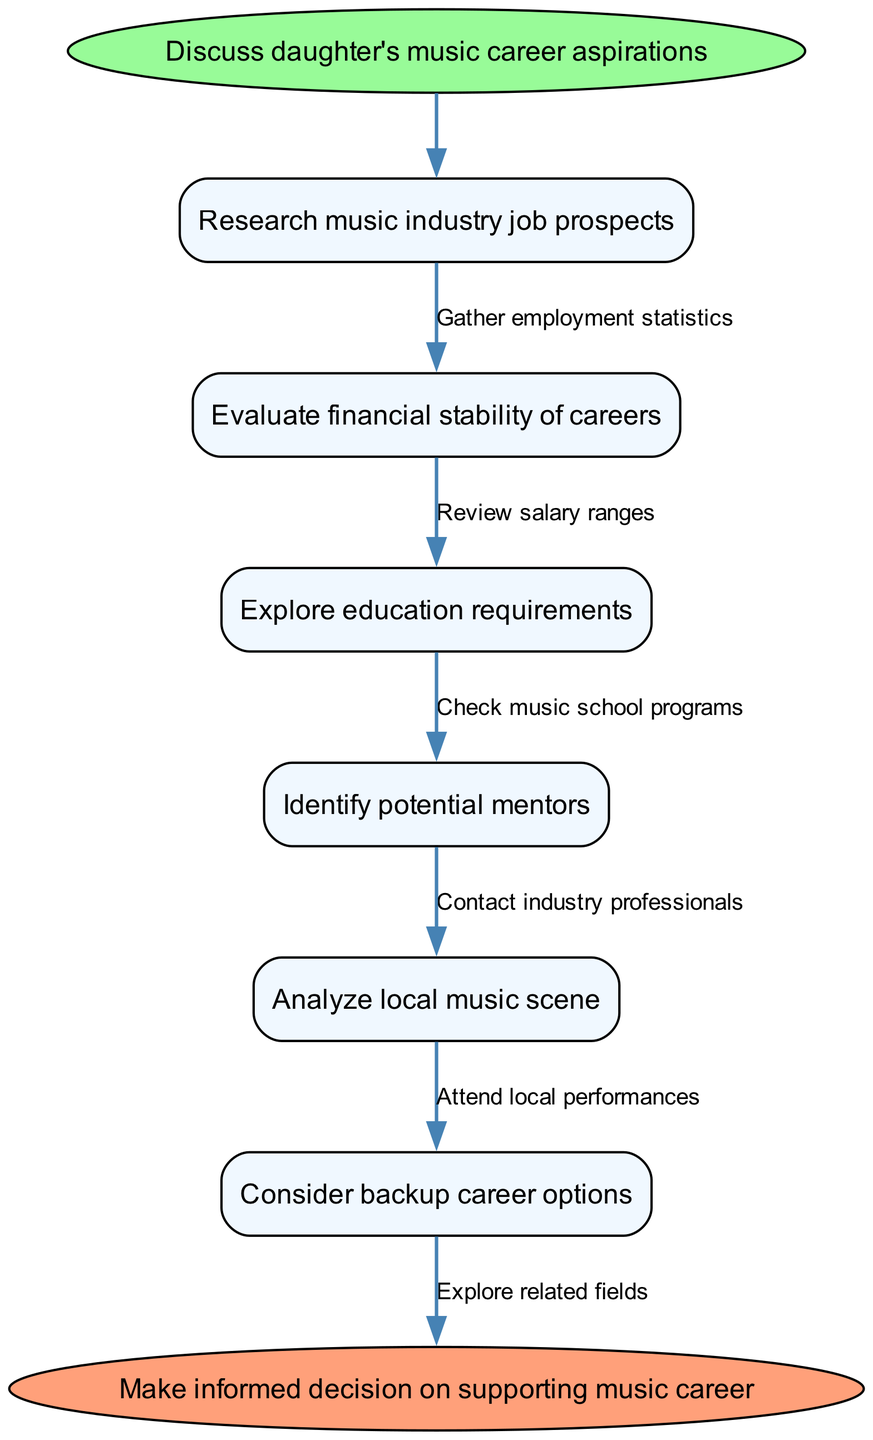What is the starting point of the flow chart? The starting point of the flow chart is indicated by a labeled ellipse node. In this case, it states "Discuss daughter's music career aspirations."
Answer: Discuss daughter's music career aspirations How many nodes are present in the diagram? By counting each unique action or stage in the flow chart, including start and end points, we find there are six nodes: 1 start node, 5 intermediate nodes, and 1 end node.
Answer: 7 What is the last step before making a decision? The last step in the flow chart, before reaching the end point, is the action labeled “Consider backup career options.” This indicates a critical evaluation step before making a final decision.
Answer: Consider backup career options Which node is directly connected to "Evaluate financial stability of careers"? The node "Evaluate financial stability of careers" is directly followed by "Explore education requirements." This means they are sequential in the flow of the diagram.
Answer: Explore education requirements What label is shown on the edge connecting "Research music industry job prospects" and the next node? The edge connecting "Research music industry job prospects" to the subsequent node is labeled "Gather employment statistics," indicating the relevant action stemming from that node.
Answer: Gather employment statistics What is the purpose of identifying potential mentors in the process? The step "Identify potential mentors" serves to connect the individual with experienced professionals, leveraging their knowledge and insights, which is crucial for navigating a music career. The connection indicates the importance of guidance in this industry.
Answer: To connect with experienced professionals How does the diagram represent the flow of actions leading to the end? The flow chart visually connects each node with directed edges that illustrate the sequence of actions taken to evaluate a music career path, culminating in an informed decision regarding support for the career.
Answer: Through directed edges indicating sequential actions 